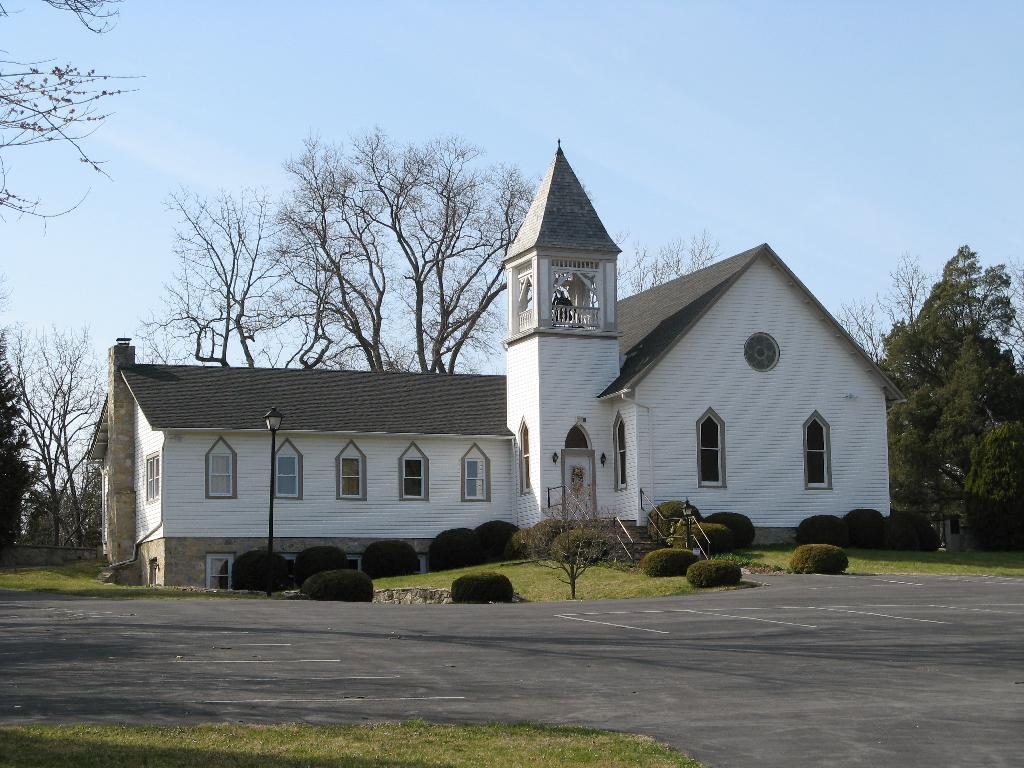What is the main structure in the center of the image? There is a house in the center of the image. What type of vegetation can be seen in the image? There are plants and grass visible in the image. What is at the bottom of the image? There is a road at the bottom of the image. What can be seen in the background of the image? Trees are visible in the background of the image. What is visible at the top of the image? The sky is visible at the top of the image. What type of silver object can be seen in the image? There is no silver object present in the image. Is there any fire visible in the image? No, there is no fire visible in the image. Did an earthquake occur in the image? There is no indication of an earthquake in the image. 